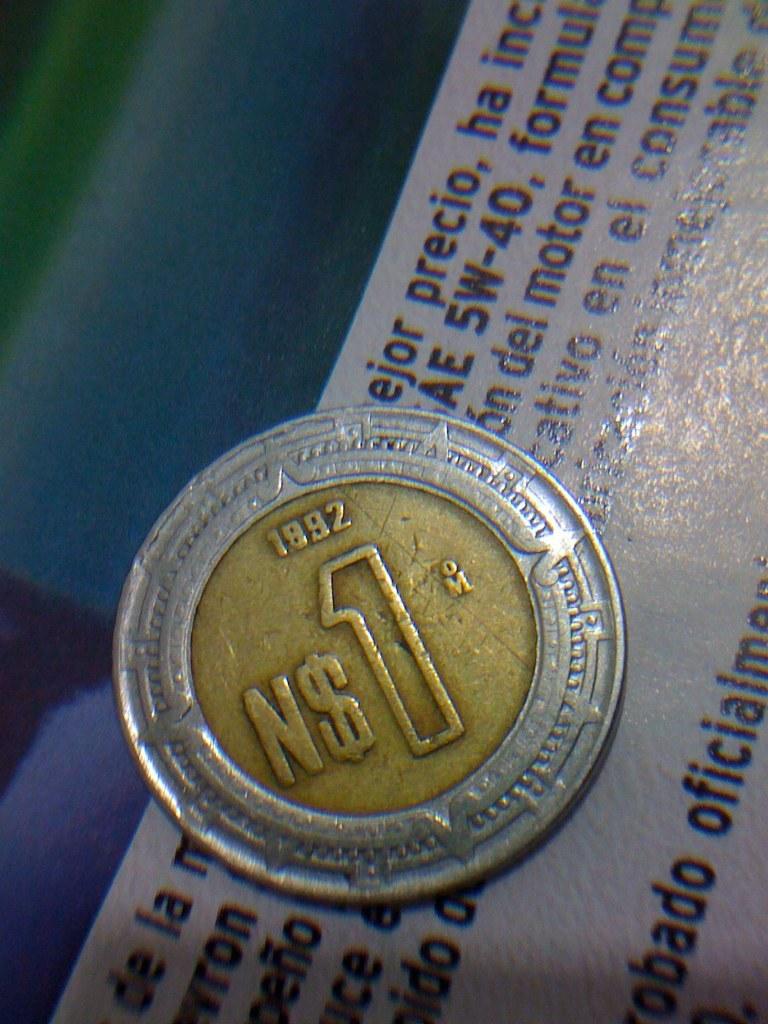What year was the coin made?
Your answer should be very brief. 1992. How much is the coin worth?
Provide a succinct answer. 1. 